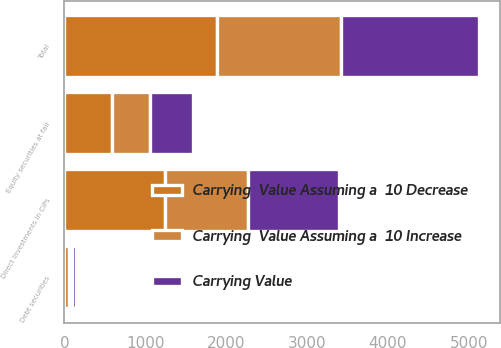Convert chart. <chart><loc_0><loc_0><loc_500><loc_500><stacked_bar_chart><ecel><fcel>Equity securities at fair<fcel>Debt securities<fcel>Direct investments in CIPs<fcel>Total<nl><fcel>Carrying Value<fcel>530<fcel>48.2<fcel>1131.6<fcel>1709.8<nl><fcel>Carrying  Value Assuming a  10 Decrease<fcel>583<fcel>53<fcel>1244.8<fcel>1880.8<nl><fcel>Carrying  Value Assuming a  10 Increase<fcel>477<fcel>43.4<fcel>1018.4<fcel>1538.8<nl></chart> 